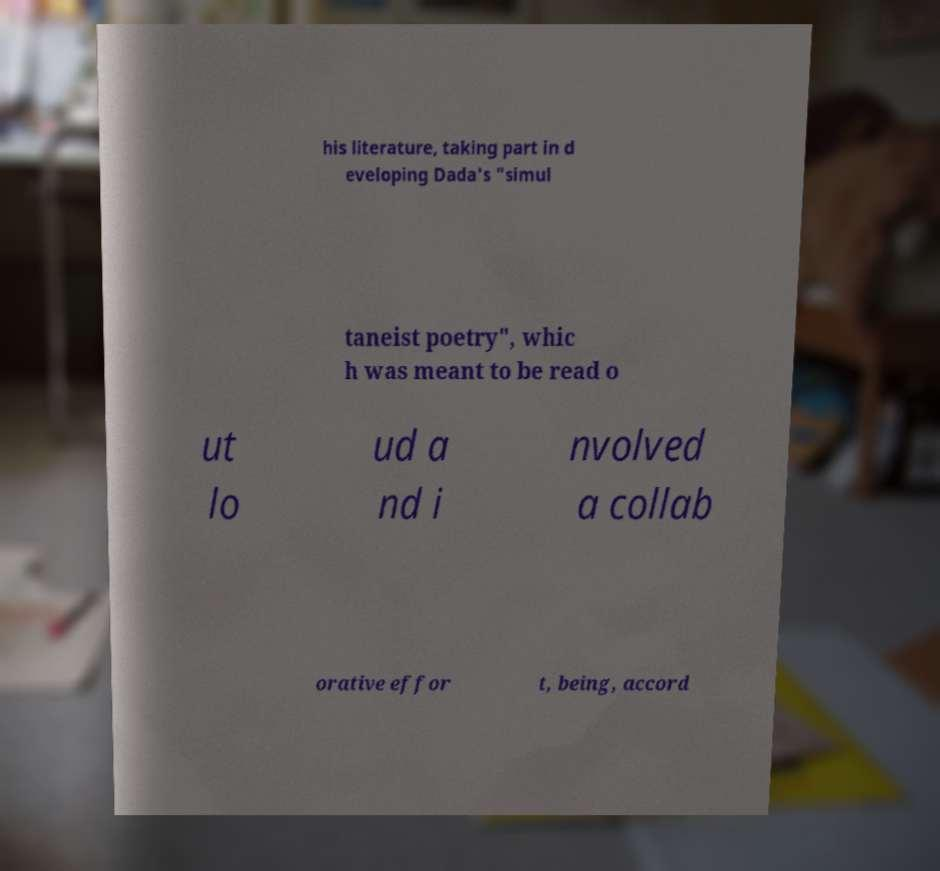Could you assist in decoding the text presented in this image and type it out clearly? his literature, taking part in d eveloping Dada's "simul taneist poetry", whic h was meant to be read o ut lo ud a nd i nvolved a collab orative effor t, being, accord 